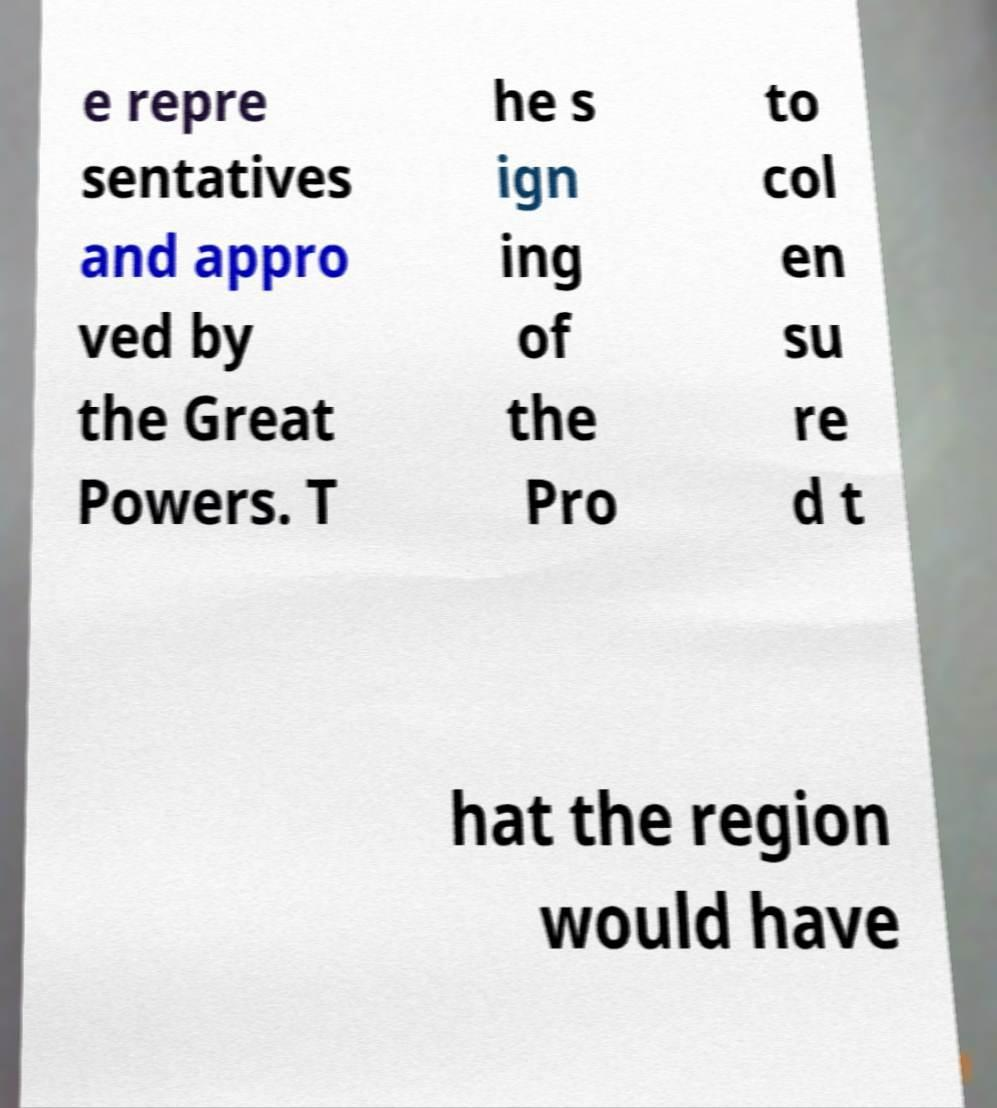For documentation purposes, I need the text within this image transcribed. Could you provide that? e repre sentatives and appro ved by the Great Powers. T he s ign ing of the Pro to col en su re d t hat the region would have 